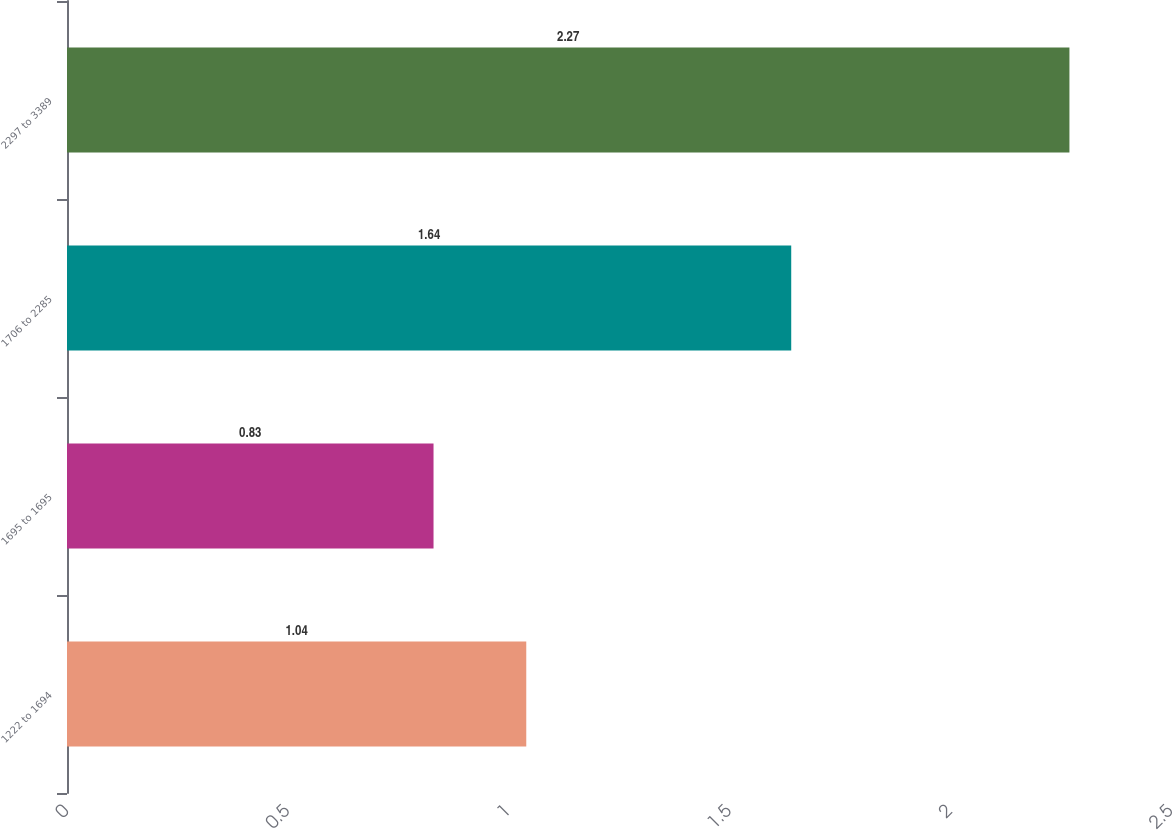Convert chart. <chart><loc_0><loc_0><loc_500><loc_500><bar_chart><fcel>1222 to 1694<fcel>1695 to 1695<fcel>1706 to 2285<fcel>2297 to 3389<nl><fcel>1.04<fcel>0.83<fcel>1.64<fcel>2.27<nl></chart> 